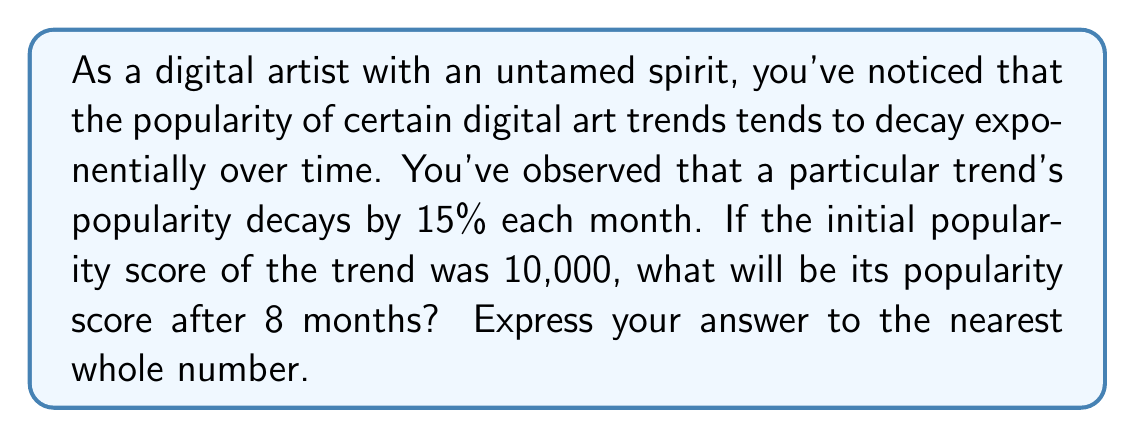Teach me how to tackle this problem. Let's approach this step-by-step using the exponential decay formula:

1) The general formula for exponential decay is:

   $$ A(t) = A_0 \cdot (1-r)^t $$

   Where:
   $A(t)$ is the amount at time $t$
   $A_0$ is the initial amount
   $r$ is the decay rate (as a decimal)
   $t$ is the time period

2) In this case:
   $A_0 = 10,000$ (initial popularity score)
   $r = 0.15$ (15% decay rate)
   $t = 8$ (8 months)

3) Plugging these values into our formula:

   $$ A(8) = 10,000 \cdot (1-0.15)^8 $$

4) Simplify inside the parentheses:

   $$ A(8) = 10,000 \cdot (0.85)^8 $$

5) Calculate $(0.85)^8$:

   $$ A(8) = 10,000 \cdot 0.2725317 $$

6) Multiply:

   $$ A(8) = 2725.317 $$

7) Rounding to the nearest whole number:

   $$ A(8) \approx 2725 $$
Answer: 2725 